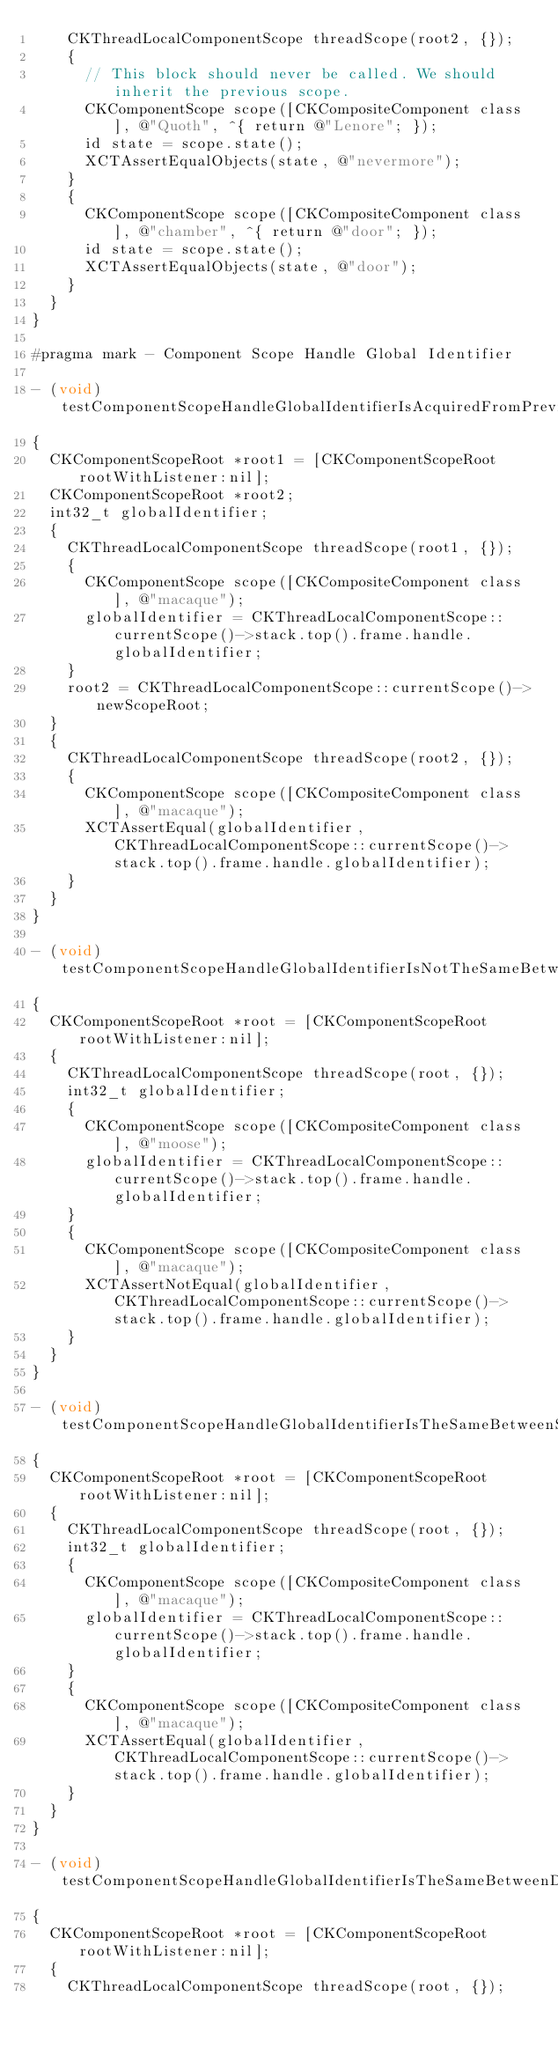Convert code to text. <code><loc_0><loc_0><loc_500><loc_500><_ObjectiveC_>    CKThreadLocalComponentScope threadScope(root2, {});
    {
      // This block should never be called. We should inherit the previous scope.
      CKComponentScope scope([CKCompositeComponent class], @"Quoth", ^{ return @"Lenore"; });
      id state = scope.state();
      XCTAssertEqualObjects(state, @"nevermore");
    }
    {
      CKComponentScope scope([CKCompositeComponent class], @"chamber", ^{ return @"door"; });
      id state = scope.state();
      XCTAssertEqualObjects(state, @"door");
    }
  }
}

#pragma mark - Component Scope Handle Global Identifier

- (void)testComponentScopeHandleGlobalIdentifierIsAcquiredFromPreviousComponentScopeOneLevelDown
{
  CKComponentScopeRoot *root1 = [CKComponentScopeRoot rootWithListener:nil];
  CKComponentScopeRoot *root2;
  int32_t globalIdentifier;
  {
    CKThreadLocalComponentScope threadScope(root1, {});
    {
      CKComponentScope scope([CKCompositeComponent class], @"macaque");
      globalIdentifier = CKThreadLocalComponentScope::currentScope()->stack.top().frame.handle.globalIdentifier;
    }
    root2 = CKThreadLocalComponentScope::currentScope()->newScopeRoot;
  }
  {
    CKThreadLocalComponentScope threadScope(root2, {});
    {
      CKComponentScope scope([CKCompositeComponent class], @"macaque");
      XCTAssertEqual(globalIdentifier, CKThreadLocalComponentScope::currentScope()->stack.top().frame.handle.globalIdentifier);
    }
  }
}

- (void)testComponentScopeHandleGlobalIdentifierIsNotTheSameBetweenSiblings
{
  CKComponentScopeRoot *root = [CKComponentScopeRoot rootWithListener:nil];
  {
    CKThreadLocalComponentScope threadScope(root, {});
    int32_t globalIdentifier;
    {
      CKComponentScope scope([CKCompositeComponent class], @"moose");
      globalIdentifier = CKThreadLocalComponentScope::currentScope()->stack.top().frame.handle.globalIdentifier;
    }
    {
      CKComponentScope scope([CKCompositeComponent class], @"macaque");
      XCTAssertNotEqual(globalIdentifier, CKThreadLocalComponentScope::currentScope()->stack.top().frame.handle.globalIdentifier);
    }
  }
}

- (void)testComponentScopeHandleGlobalIdentifierIsTheSameBetweenSiblingsWithComponentScopeCollision
{
  CKComponentScopeRoot *root = [CKComponentScopeRoot rootWithListener:nil];
  {
    CKThreadLocalComponentScope threadScope(root, {});
    int32_t globalIdentifier;
    {
      CKComponentScope scope([CKCompositeComponent class], @"macaque");
      globalIdentifier = CKThreadLocalComponentScope::currentScope()->stack.top().frame.handle.globalIdentifier;
    }
    {
      CKComponentScope scope([CKCompositeComponent class], @"macaque");
      XCTAssertEqual(globalIdentifier, CKThreadLocalComponentScope::currentScope()->stack.top().frame.handle.globalIdentifier);
    }
  }
}

- (void)testComponentScopeHandleGlobalIdentifierIsTheSameBetweenDescendantsWithComponentScopeCollision
{
  CKComponentScopeRoot *root = [CKComponentScopeRoot rootWithListener:nil];
  {
    CKThreadLocalComponentScope threadScope(root, {});</code> 